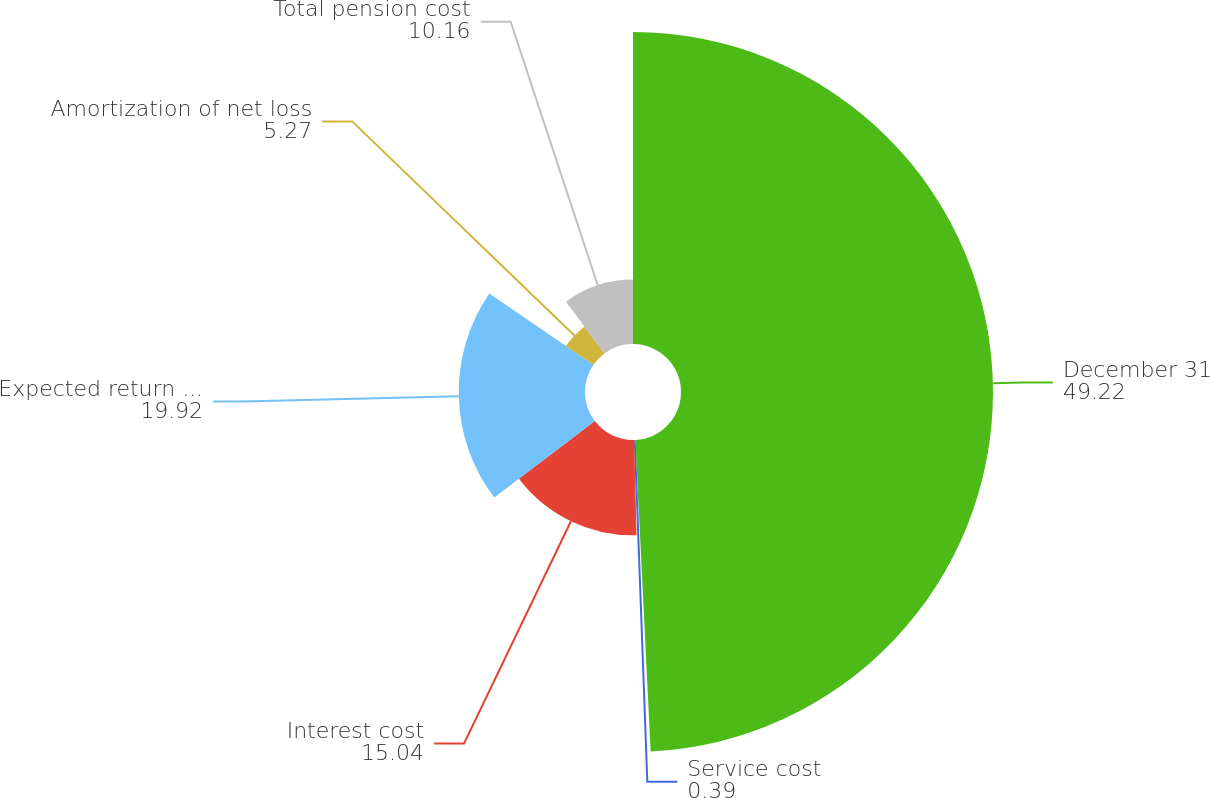<chart> <loc_0><loc_0><loc_500><loc_500><pie_chart><fcel>December 31<fcel>Service cost<fcel>Interest cost<fcel>Expected return on plan assets<fcel>Amortization of net loss<fcel>Total pension cost<nl><fcel>49.22%<fcel>0.39%<fcel>15.04%<fcel>19.92%<fcel>5.27%<fcel>10.16%<nl></chart> 